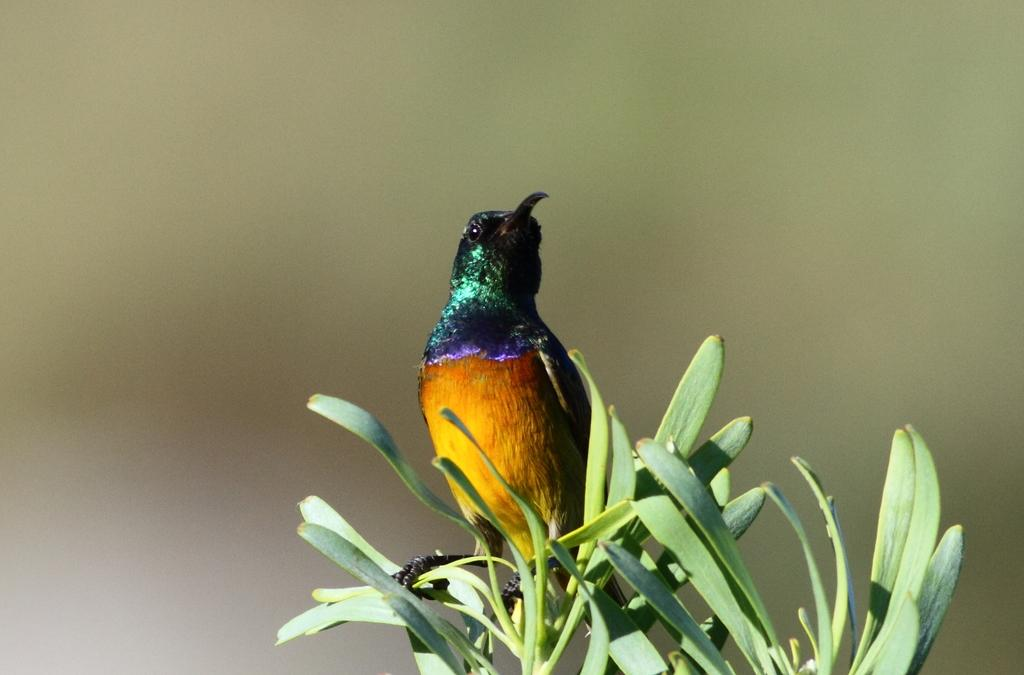What type of animal is in the image? There is a bird in the image. What colors can be seen on the bird? The bird has yellow, orange, violet, green, and black colors. What else is present in the image besides the bird? There is a green plant in the image. Where is the bird located in relation to the plant? The bird is on the plant. How would you describe the background of the image? The background of the image is blurry. Can you hear the bird's ear in the image? There is no ear present in the image, as it is a bird and not a human or animal with ears. 